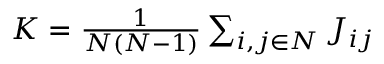<formula> <loc_0><loc_0><loc_500><loc_500>\begin{array} { r } { K = \frac { 1 } { N ( N - 1 ) } \sum _ { i , j \in N } J _ { i j } } \end{array}</formula> 